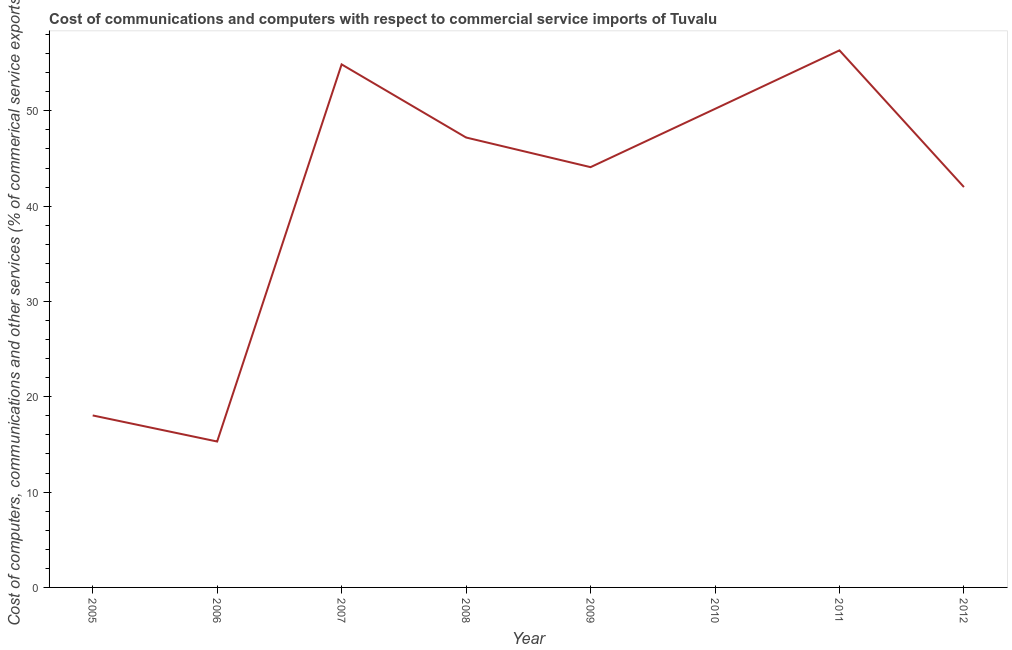What is the  computer and other services in 2007?
Give a very brief answer. 54.87. Across all years, what is the maximum cost of communications?
Ensure brevity in your answer.  56.34. Across all years, what is the minimum cost of communications?
Keep it short and to the point. 15.31. What is the sum of the cost of communications?
Your answer should be compact. 328.05. What is the difference between the cost of communications in 2005 and 2007?
Your answer should be very brief. -36.83. What is the average  computer and other services per year?
Your response must be concise. 41.01. What is the median cost of communications?
Ensure brevity in your answer.  45.64. In how many years, is the  computer and other services greater than 54 %?
Offer a terse response. 2. What is the ratio of the cost of communications in 2005 to that in 2009?
Your answer should be compact. 0.41. Is the cost of communications in 2008 less than that in 2012?
Ensure brevity in your answer.  No. What is the difference between the highest and the second highest  computer and other services?
Your answer should be compact. 1.47. What is the difference between the highest and the lowest cost of communications?
Make the answer very short. 41.03. In how many years, is the cost of communications greater than the average cost of communications taken over all years?
Provide a succinct answer. 6. Does the  computer and other services monotonically increase over the years?
Provide a short and direct response. No. What is the difference between two consecutive major ticks on the Y-axis?
Your response must be concise. 10. Does the graph contain any zero values?
Offer a very short reply. No. Does the graph contain grids?
Provide a short and direct response. No. What is the title of the graph?
Provide a succinct answer. Cost of communications and computers with respect to commercial service imports of Tuvalu. What is the label or title of the Y-axis?
Your answer should be very brief. Cost of computers, communications and other services (% of commerical service exports). What is the Cost of computers, communications and other services (% of commerical service exports) in 2005?
Your answer should be very brief. 18.04. What is the Cost of computers, communications and other services (% of commerical service exports) of 2006?
Your answer should be very brief. 15.31. What is the Cost of computers, communications and other services (% of commerical service exports) in 2007?
Your answer should be compact. 54.87. What is the Cost of computers, communications and other services (% of commerical service exports) of 2008?
Keep it short and to the point. 47.2. What is the Cost of computers, communications and other services (% of commerical service exports) in 2009?
Keep it short and to the point. 44.09. What is the Cost of computers, communications and other services (% of commerical service exports) of 2010?
Make the answer very short. 50.2. What is the Cost of computers, communications and other services (% of commerical service exports) of 2011?
Offer a very short reply. 56.34. What is the Cost of computers, communications and other services (% of commerical service exports) in 2012?
Offer a very short reply. 42. What is the difference between the Cost of computers, communications and other services (% of commerical service exports) in 2005 and 2006?
Your response must be concise. 2.74. What is the difference between the Cost of computers, communications and other services (% of commerical service exports) in 2005 and 2007?
Make the answer very short. -36.83. What is the difference between the Cost of computers, communications and other services (% of commerical service exports) in 2005 and 2008?
Your answer should be compact. -29.15. What is the difference between the Cost of computers, communications and other services (% of commerical service exports) in 2005 and 2009?
Make the answer very short. -26.05. What is the difference between the Cost of computers, communications and other services (% of commerical service exports) in 2005 and 2010?
Offer a very short reply. -32.16. What is the difference between the Cost of computers, communications and other services (% of commerical service exports) in 2005 and 2011?
Give a very brief answer. -38.29. What is the difference between the Cost of computers, communications and other services (% of commerical service exports) in 2005 and 2012?
Ensure brevity in your answer.  -23.96. What is the difference between the Cost of computers, communications and other services (% of commerical service exports) in 2006 and 2007?
Offer a very short reply. -39.56. What is the difference between the Cost of computers, communications and other services (% of commerical service exports) in 2006 and 2008?
Offer a terse response. -31.89. What is the difference between the Cost of computers, communications and other services (% of commerical service exports) in 2006 and 2009?
Offer a very short reply. -28.78. What is the difference between the Cost of computers, communications and other services (% of commerical service exports) in 2006 and 2010?
Give a very brief answer. -34.9. What is the difference between the Cost of computers, communications and other services (% of commerical service exports) in 2006 and 2011?
Your answer should be very brief. -41.03. What is the difference between the Cost of computers, communications and other services (% of commerical service exports) in 2006 and 2012?
Offer a terse response. -26.69. What is the difference between the Cost of computers, communications and other services (% of commerical service exports) in 2007 and 2008?
Provide a short and direct response. 7.67. What is the difference between the Cost of computers, communications and other services (% of commerical service exports) in 2007 and 2009?
Your answer should be compact. 10.78. What is the difference between the Cost of computers, communications and other services (% of commerical service exports) in 2007 and 2010?
Make the answer very short. 4.67. What is the difference between the Cost of computers, communications and other services (% of commerical service exports) in 2007 and 2011?
Make the answer very short. -1.47. What is the difference between the Cost of computers, communications and other services (% of commerical service exports) in 2007 and 2012?
Your response must be concise. 12.87. What is the difference between the Cost of computers, communications and other services (% of commerical service exports) in 2008 and 2009?
Make the answer very short. 3.11. What is the difference between the Cost of computers, communications and other services (% of commerical service exports) in 2008 and 2010?
Keep it short and to the point. -3. What is the difference between the Cost of computers, communications and other services (% of commerical service exports) in 2008 and 2011?
Provide a succinct answer. -9.14. What is the difference between the Cost of computers, communications and other services (% of commerical service exports) in 2008 and 2012?
Your answer should be very brief. 5.2. What is the difference between the Cost of computers, communications and other services (% of commerical service exports) in 2009 and 2010?
Offer a terse response. -6.11. What is the difference between the Cost of computers, communications and other services (% of commerical service exports) in 2009 and 2011?
Provide a succinct answer. -12.25. What is the difference between the Cost of computers, communications and other services (% of commerical service exports) in 2009 and 2012?
Offer a terse response. 2.09. What is the difference between the Cost of computers, communications and other services (% of commerical service exports) in 2010 and 2011?
Ensure brevity in your answer.  -6.14. What is the difference between the Cost of computers, communications and other services (% of commerical service exports) in 2010 and 2012?
Ensure brevity in your answer.  8.2. What is the difference between the Cost of computers, communications and other services (% of commerical service exports) in 2011 and 2012?
Your answer should be very brief. 14.34. What is the ratio of the Cost of computers, communications and other services (% of commerical service exports) in 2005 to that in 2006?
Provide a short and direct response. 1.18. What is the ratio of the Cost of computers, communications and other services (% of commerical service exports) in 2005 to that in 2007?
Provide a short and direct response. 0.33. What is the ratio of the Cost of computers, communications and other services (% of commerical service exports) in 2005 to that in 2008?
Make the answer very short. 0.38. What is the ratio of the Cost of computers, communications and other services (% of commerical service exports) in 2005 to that in 2009?
Your answer should be compact. 0.41. What is the ratio of the Cost of computers, communications and other services (% of commerical service exports) in 2005 to that in 2010?
Provide a short and direct response. 0.36. What is the ratio of the Cost of computers, communications and other services (% of commerical service exports) in 2005 to that in 2011?
Your answer should be compact. 0.32. What is the ratio of the Cost of computers, communications and other services (% of commerical service exports) in 2005 to that in 2012?
Offer a very short reply. 0.43. What is the ratio of the Cost of computers, communications and other services (% of commerical service exports) in 2006 to that in 2007?
Keep it short and to the point. 0.28. What is the ratio of the Cost of computers, communications and other services (% of commerical service exports) in 2006 to that in 2008?
Your response must be concise. 0.32. What is the ratio of the Cost of computers, communications and other services (% of commerical service exports) in 2006 to that in 2009?
Make the answer very short. 0.35. What is the ratio of the Cost of computers, communications and other services (% of commerical service exports) in 2006 to that in 2010?
Offer a very short reply. 0.3. What is the ratio of the Cost of computers, communications and other services (% of commerical service exports) in 2006 to that in 2011?
Your answer should be very brief. 0.27. What is the ratio of the Cost of computers, communications and other services (% of commerical service exports) in 2006 to that in 2012?
Your response must be concise. 0.36. What is the ratio of the Cost of computers, communications and other services (% of commerical service exports) in 2007 to that in 2008?
Offer a terse response. 1.16. What is the ratio of the Cost of computers, communications and other services (% of commerical service exports) in 2007 to that in 2009?
Provide a succinct answer. 1.25. What is the ratio of the Cost of computers, communications and other services (% of commerical service exports) in 2007 to that in 2010?
Give a very brief answer. 1.09. What is the ratio of the Cost of computers, communications and other services (% of commerical service exports) in 2007 to that in 2011?
Provide a succinct answer. 0.97. What is the ratio of the Cost of computers, communications and other services (% of commerical service exports) in 2007 to that in 2012?
Keep it short and to the point. 1.31. What is the ratio of the Cost of computers, communications and other services (% of commerical service exports) in 2008 to that in 2009?
Keep it short and to the point. 1.07. What is the ratio of the Cost of computers, communications and other services (% of commerical service exports) in 2008 to that in 2010?
Offer a very short reply. 0.94. What is the ratio of the Cost of computers, communications and other services (% of commerical service exports) in 2008 to that in 2011?
Offer a very short reply. 0.84. What is the ratio of the Cost of computers, communications and other services (% of commerical service exports) in 2008 to that in 2012?
Your response must be concise. 1.12. What is the ratio of the Cost of computers, communications and other services (% of commerical service exports) in 2009 to that in 2010?
Ensure brevity in your answer.  0.88. What is the ratio of the Cost of computers, communications and other services (% of commerical service exports) in 2009 to that in 2011?
Provide a short and direct response. 0.78. What is the ratio of the Cost of computers, communications and other services (% of commerical service exports) in 2010 to that in 2011?
Ensure brevity in your answer.  0.89. What is the ratio of the Cost of computers, communications and other services (% of commerical service exports) in 2010 to that in 2012?
Offer a very short reply. 1.2. What is the ratio of the Cost of computers, communications and other services (% of commerical service exports) in 2011 to that in 2012?
Give a very brief answer. 1.34. 